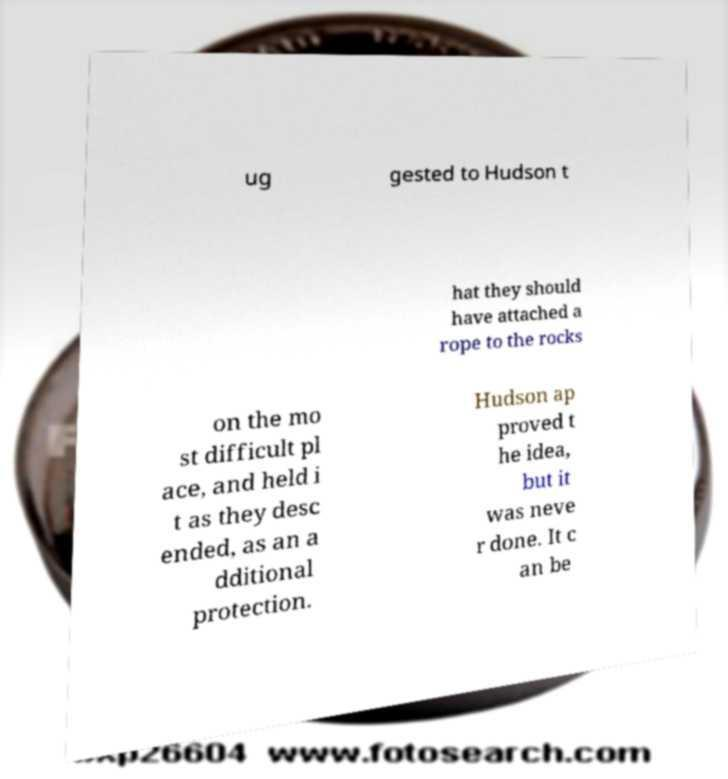What messages or text are displayed in this image? I need them in a readable, typed format. ug gested to Hudson t hat they should have attached a rope to the rocks on the mo st difficult pl ace, and held i t as they desc ended, as an a dditional protection. Hudson ap proved t he idea, but it was neve r done. It c an be 